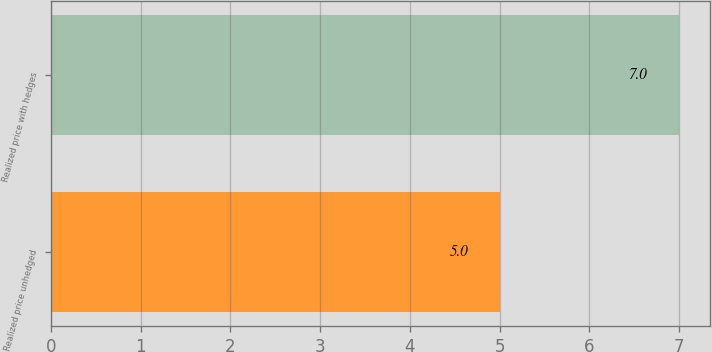Convert chart. <chart><loc_0><loc_0><loc_500><loc_500><bar_chart><fcel>Realized price unhedged<fcel>Realized price with hedges<nl><fcel>5<fcel>7<nl></chart> 